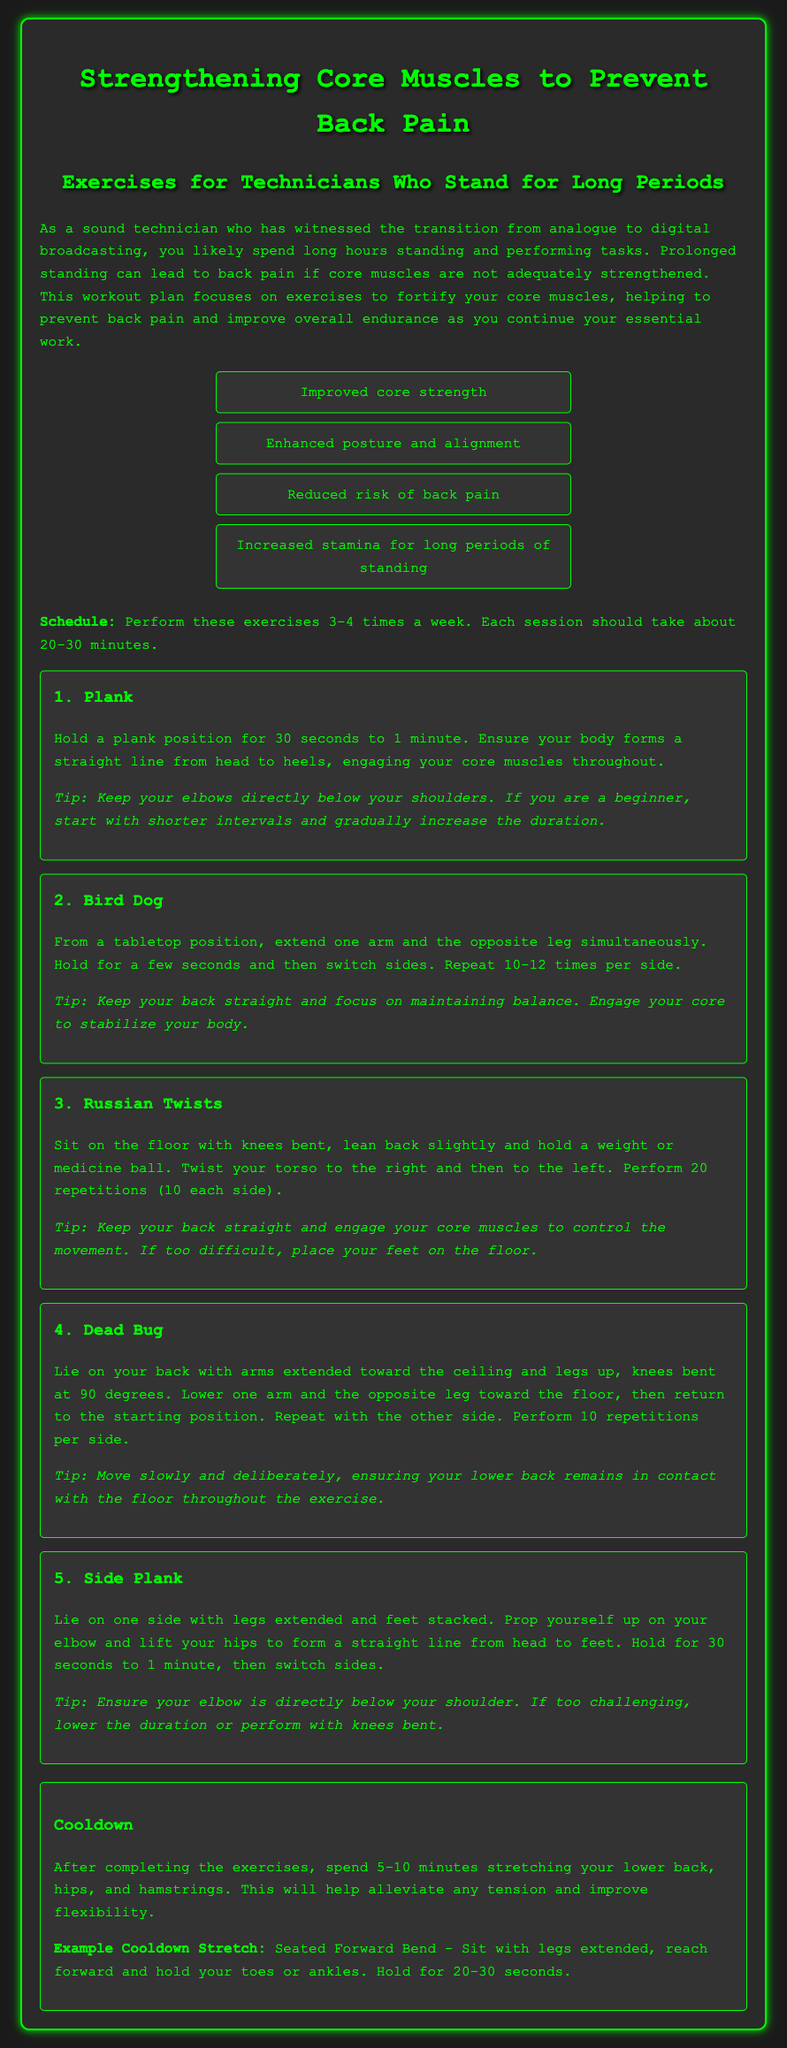what are the benefits of core strengthening? The document lists four benefits of core strengthening, which are improved core strength, enhanced posture and alignment, reduced risk of back pain, and increased stamina for long periods of standing.
Answer: improved core strength, enhanced posture and alignment, reduced risk of back pain, increased stamina for long periods of standing how many times a week should the exercises be performed? The schedule mentioned in the document recommends performing the exercises 3-4 times a week.
Answer: 3-4 times what is the duration for holding a plank? The document specifies holding a plank for 30 seconds to 1 minute.
Answer: 30 seconds to 1 minute how many repetitions are recommended for Russian Twists? The exercises section in the document states to perform 20 repetitions (10 each side) for Russian Twists.
Answer: 20 repetitions (10 each side) what should be done after completing the exercises? The document suggests spending 5-10 minutes stretching the lower back, hips, and hamstrings after completing the exercises.
Answer: stretching the lower back, hips, and hamstrings which exercise involves extending one arm and the opposite leg? From the exercises described, the Bird Dog involves extending one arm and the opposite leg.
Answer: Bird Dog 